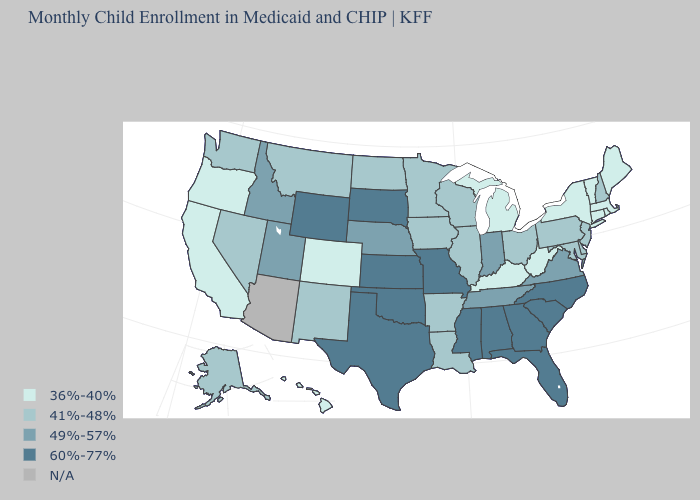What is the lowest value in the USA?
Give a very brief answer. 36%-40%. Name the states that have a value in the range 60%-77%?
Quick response, please. Alabama, Florida, Georgia, Kansas, Mississippi, Missouri, North Carolina, Oklahoma, South Carolina, South Dakota, Texas, Wyoming. What is the value of Texas?
Concise answer only. 60%-77%. Which states have the lowest value in the Northeast?
Keep it brief. Connecticut, Maine, Massachusetts, New York, Rhode Island, Vermont. Which states have the lowest value in the USA?
Be succinct. California, Colorado, Connecticut, Hawaii, Kentucky, Maine, Massachusetts, Michigan, New York, Oregon, Rhode Island, Vermont, West Virginia. Does Nevada have the lowest value in the West?
Write a very short answer. No. Among the states that border Colorado , which have the highest value?
Be succinct. Kansas, Oklahoma, Wyoming. Name the states that have a value in the range N/A?
Answer briefly. Arizona. Among the states that border New York , which have the highest value?
Write a very short answer. New Jersey, Pennsylvania. What is the value of Nevada?
Give a very brief answer. 41%-48%. Is the legend a continuous bar?
Answer briefly. No. How many symbols are there in the legend?
Give a very brief answer. 5. Name the states that have a value in the range 49%-57%?
Write a very short answer. Idaho, Indiana, Nebraska, Tennessee, Utah, Virginia. Which states have the lowest value in the West?
Be succinct. California, Colorado, Hawaii, Oregon. Among the states that border Oregon , which have the highest value?
Concise answer only. Idaho. 